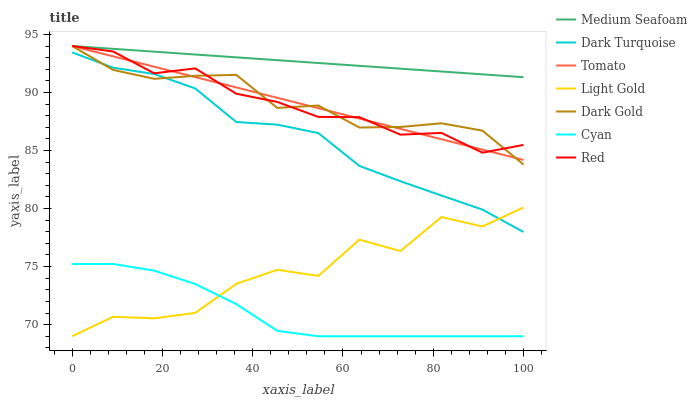Does Cyan have the minimum area under the curve?
Answer yes or no. Yes. Does Medium Seafoam have the maximum area under the curve?
Answer yes or no. Yes. Does Dark Gold have the minimum area under the curve?
Answer yes or no. No. Does Dark Gold have the maximum area under the curve?
Answer yes or no. No. Is Tomato the smoothest?
Answer yes or no. Yes. Is Light Gold the roughest?
Answer yes or no. Yes. Is Dark Gold the smoothest?
Answer yes or no. No. Is Dark Gold the roughest?
Answer yes or no. No. Does Cyan have the lowest value?
Answer yes or no. Yes. Does Dark Gold have the lowest value?
Answer yes or no. No. Does Red have the highest value?
Answer yes or no. Yes. Does Dark Turquoise have the highest value?
Answer yes or no. No. Is Cyan less than Tomato?
Answer yes or no. Yes. Is Medium Seafoam greater than Cyan?
Answer yes or no. Yes. Does Dark Gold intersect Medium Seafoam?
Answer yes or no. Yes. Is Dark Gold less than Medium Seafoam?
Answer yes or no. No. Is Dark Gold greater than Medium Seafoam?
Answer yes or no. No. Does Cyan intersect Tomato?
Answer yes or no. No. 